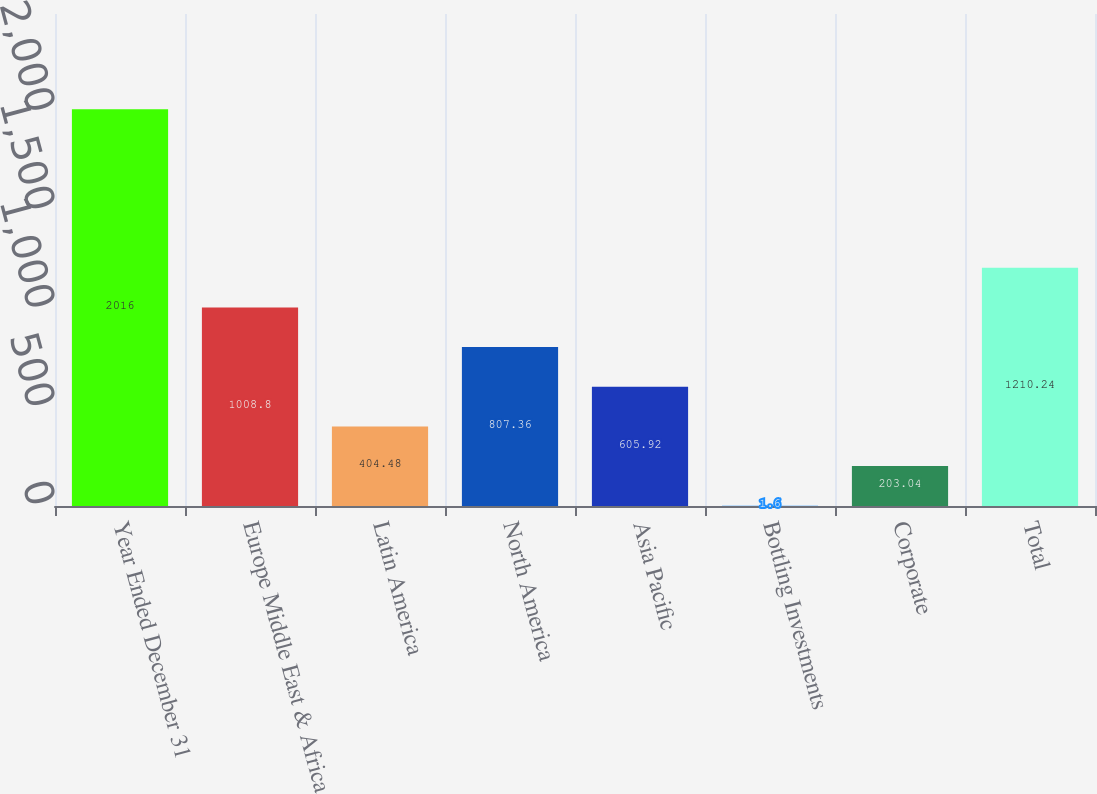Convert chart to OTSL. <chart><loc_0><loc_0><loc_500><loc_500><bar_chart><fcel>Year Ended December 31<fcel>Europe Middle East & Africa<fcel>Latin America<fcel>North America<fcel>Asia Pacific<fcel>Bottling Investments<fcel>Corporate<fcel>Total<nl><fcel>2016<fcel>1008.8<fcel>404.48<fcel>807.36<fcel>605.92<fcel>1.6<fcel>203.04<fcel>1210.24<nl></chart> 